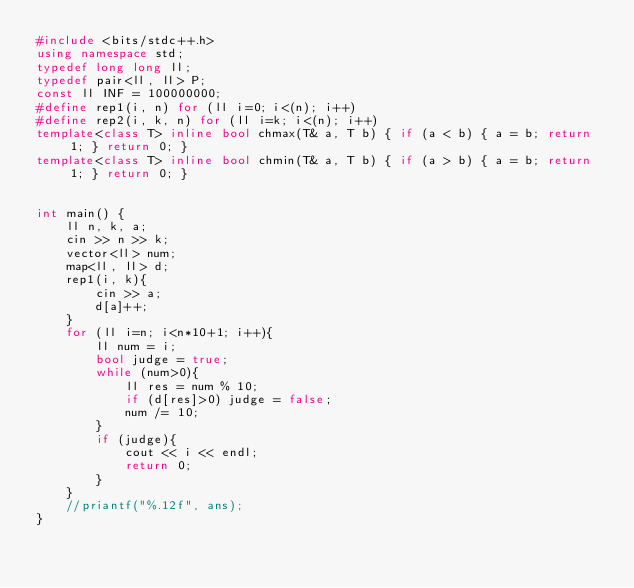<code> <loc_0><loc_0><loc_500><loc_500><_C++_>#include <bits/stdc++.h>
using namespace std;
typedef long long ll;
typedef pair<ll, ll> P;
const ll INF = 100000000;
#define rep1(i, n) for (ll i=0; i<(n); i++) 
#define rep2(i, k, n) for (ll i=k; i<(n); i++)
template<class T> inline bool chmax(T& a, T b) { if (a < b) { a = b; return 1; } return 0; }
template<class T> inline bool chmin(T& a, T b) { if (a > b) { a = b; return 1; } return 0; }


int main() {
    ll n, k, a;
    cin >> n >> k;
    vector<ll> num;
    map<ll, ll> d;
    rep1(i, k){
        cin >> a;
        d[a]++;
    }
    for (ll i=n; i<n*10+1; i++){
        ll num = i;
        bool judge = true;
        while (num>0){
            ll res = num % 10;
            if (d[res]>0) judge = false; 
            num /= 10;
        }
        if (judge){
            cout << i << endl;
            return 0;
        }
    }
    //priantf("%.12f", ans);
}</code> 